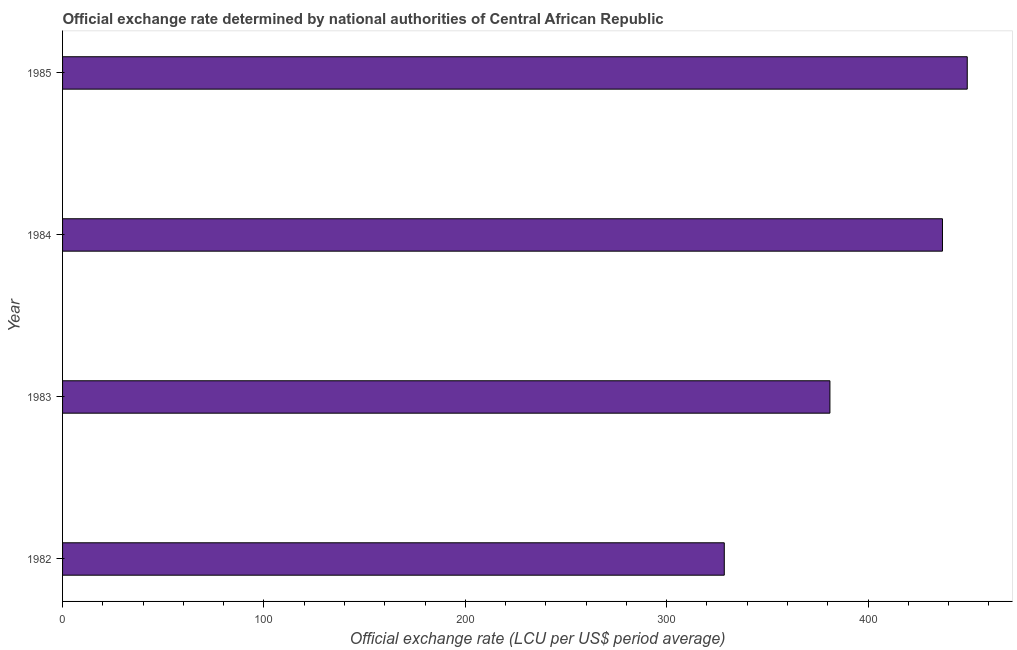What is the title of the graph?
Provide a succinct answer. Official exchange rate determined by national authorities of Central African Republic. What is the label or title of the X-axis?
Provide a succinct answer. Official exchange rate (LCU per US$ period average). What is the official exchange rate in 1982?
Your answer should be compact. 328.61. Across all years, what is the maximum official exchange rate?
Offer a terse response. 449.26. Across all years, what is the minimum official exchange rate?
Your answer should be very brief. 328.61. In which year was the official exchange rate minimum?
Make the answer very short. 1982. What is the sum of the official exchange rate?
Offer a very short reply. 1595.89. What is the difference between the official exchange rate in 1983 and 1985?
Your answer should be compact. -68.2. What is the average official exchange rate per year?
Keep it short and to the point. 398.97. What is the median official exchange rate?
Your response must be concise. 409.01. In how many years, is the official exchange rate greater than 20 ?
Ensure brevity in your answer.  4. Do a majority of the years between 1984 and 1985 (inclusive) have official exchange rate greater than 360 ?
Your answer should be compact. Yes. What is the ratio of the official exchange rate in 1983 to that in 1984?
Offer a very short reply. 0.87. Is the official exchange rate in 1983 less than that in 1984?
Give a very brief answer. Yes. Is the difference between the official exchange rate in 1982 and 1983 greater than the difference between any two years?
Give a very brief answer. No. What is the difference between the highest and the second highest official exchange rate?
Provide a succinct answer. 12.31. What is the difference between the highest and the lowest official exchange rate?
Provide a short and direct response. 120.66. In how many years, is the official exchange rate greater than the average official exchange rate taken over all years?
Give a very brief answer. 2. How many bars are there?
Provide a succinct answer. 4. What is the difference between two consecutive major ticks on the X-axis?
Your answer should be compact. 100. What is the Official exchange rate (LCU per US$ period average) of 1982?
Your response must be concise. 328.61. What is the Official exchange rate (LCU per US$ period average) in 1983?
Give a very brief answer. 381.07. What is the Official exchange rate (LCU per US$ period average) of 1984?
Your response must be concise. 436.96. What is the Official exchange rate (LCU per US$ period average) in 1985?
Keep it short and to the point. 449.26. What is the difference between the Official exchange rate (LCU per US$ period average) in 1982 and 1983?
Your answer should be very brief. -52.46. What is the difference between the Official exchange rate (LCU per US$ period average) in 1982 and 1984?
Make the answer very short. -108.35. What is the difference between the Official exchange rate (LCU per US$ period average) in 1982 and 1985?
Ensure brevity in your answer.  -120.66. What is the difference between the Official exchange rate (LCU per US$ period average) in 1983 and 1984?
Offer a terse response. -55.89. What is the difference between the Official exchange rate (LCU per US$ period average) in 1983 and 1985?
Provide a short and direct response. -68.2. What is the difference between the Official exchange rate (LCU per US$ period average) in 1984 and 1985?
Your response must be concise. -12.31. What is the ratio of the Official exchange rate (LCU per US$ period average) in 1982 to that in 1983?
Offer a terse response. 0.86. What is the ratio of the Official exchange rate (LCU per US$ period average) in 1982 to that in 1984?
Provide a succinct answer. 0.75. What is the ratio of the Official exchange rate (LCU per US$ period average) in 1982 to that in 1985?
Provide a succinct answer. 0.73. What is the ratio of the Official exchange rate (LCU per US$ period average) in 1983 to that in 1984?
Provide a short and direct response. 0.87. What is the ratio of the Official exchange rate (LCU per US$ period average) in 1983 to that in 1985?
Provide a short and direct response. 0.85. What is the ratio of the Official exchange rate (LCU per US$ period average) in 1984 to that in 1985?
Your answer should be very brief. 0.97. 